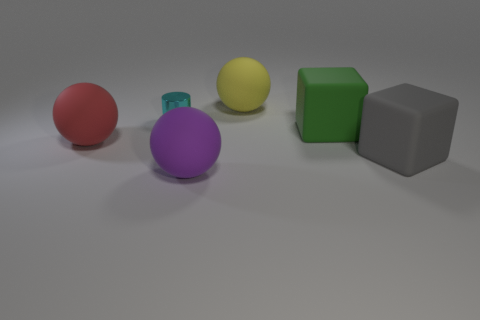Is there anything else that has the same size as the cyan thing?
Provide a short and direct response. No. How many objects are big rubber balls that are to the left of the yellow rubber object or large spheres on the right side of the purple object?
Give a very brief answer. 3. What is the material of the big gray thing?
Keep it short and to the point. Rubber. What number of other things are the same size as the cyan cylinder?
Make the answer very short. 0. How big is the rubber thing behind the metallic thing?
Keep it short and to the point. Large. There is a sphere that is in front of the matte ball on the left side of the small cyan shiny cylinder that is behind the red object; what is it made of?
Your response must be concise. Rubber. Is the tiny object the same shape as the big gray thing?
Make the answer very short. No. What number of rubber objects are either tiny cyan things or big blue cubes?
Provide a succinct answer. 0. What number of tiny red rubber cylinders are there?
Make the answer very short. 0. The block that is the same size as the gray matte thing is what color?
Give a very brief answer. Green. 